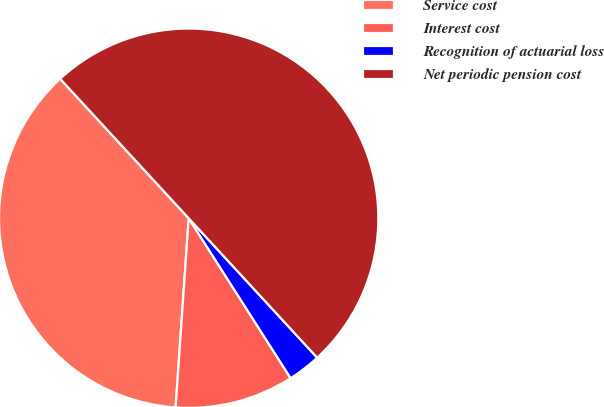<chart> <loc_0><loc_0><loc_500><loc_500><pie_chart><fcel>Service cost<fcel>Interest cost<fcel>Recognition of actuarial loss<fcel>Net periodic pension cost<nl><fcel>37.05%<fcel>10.13%<fcel>2.82%<fcel>50.0%<nl></chart> 